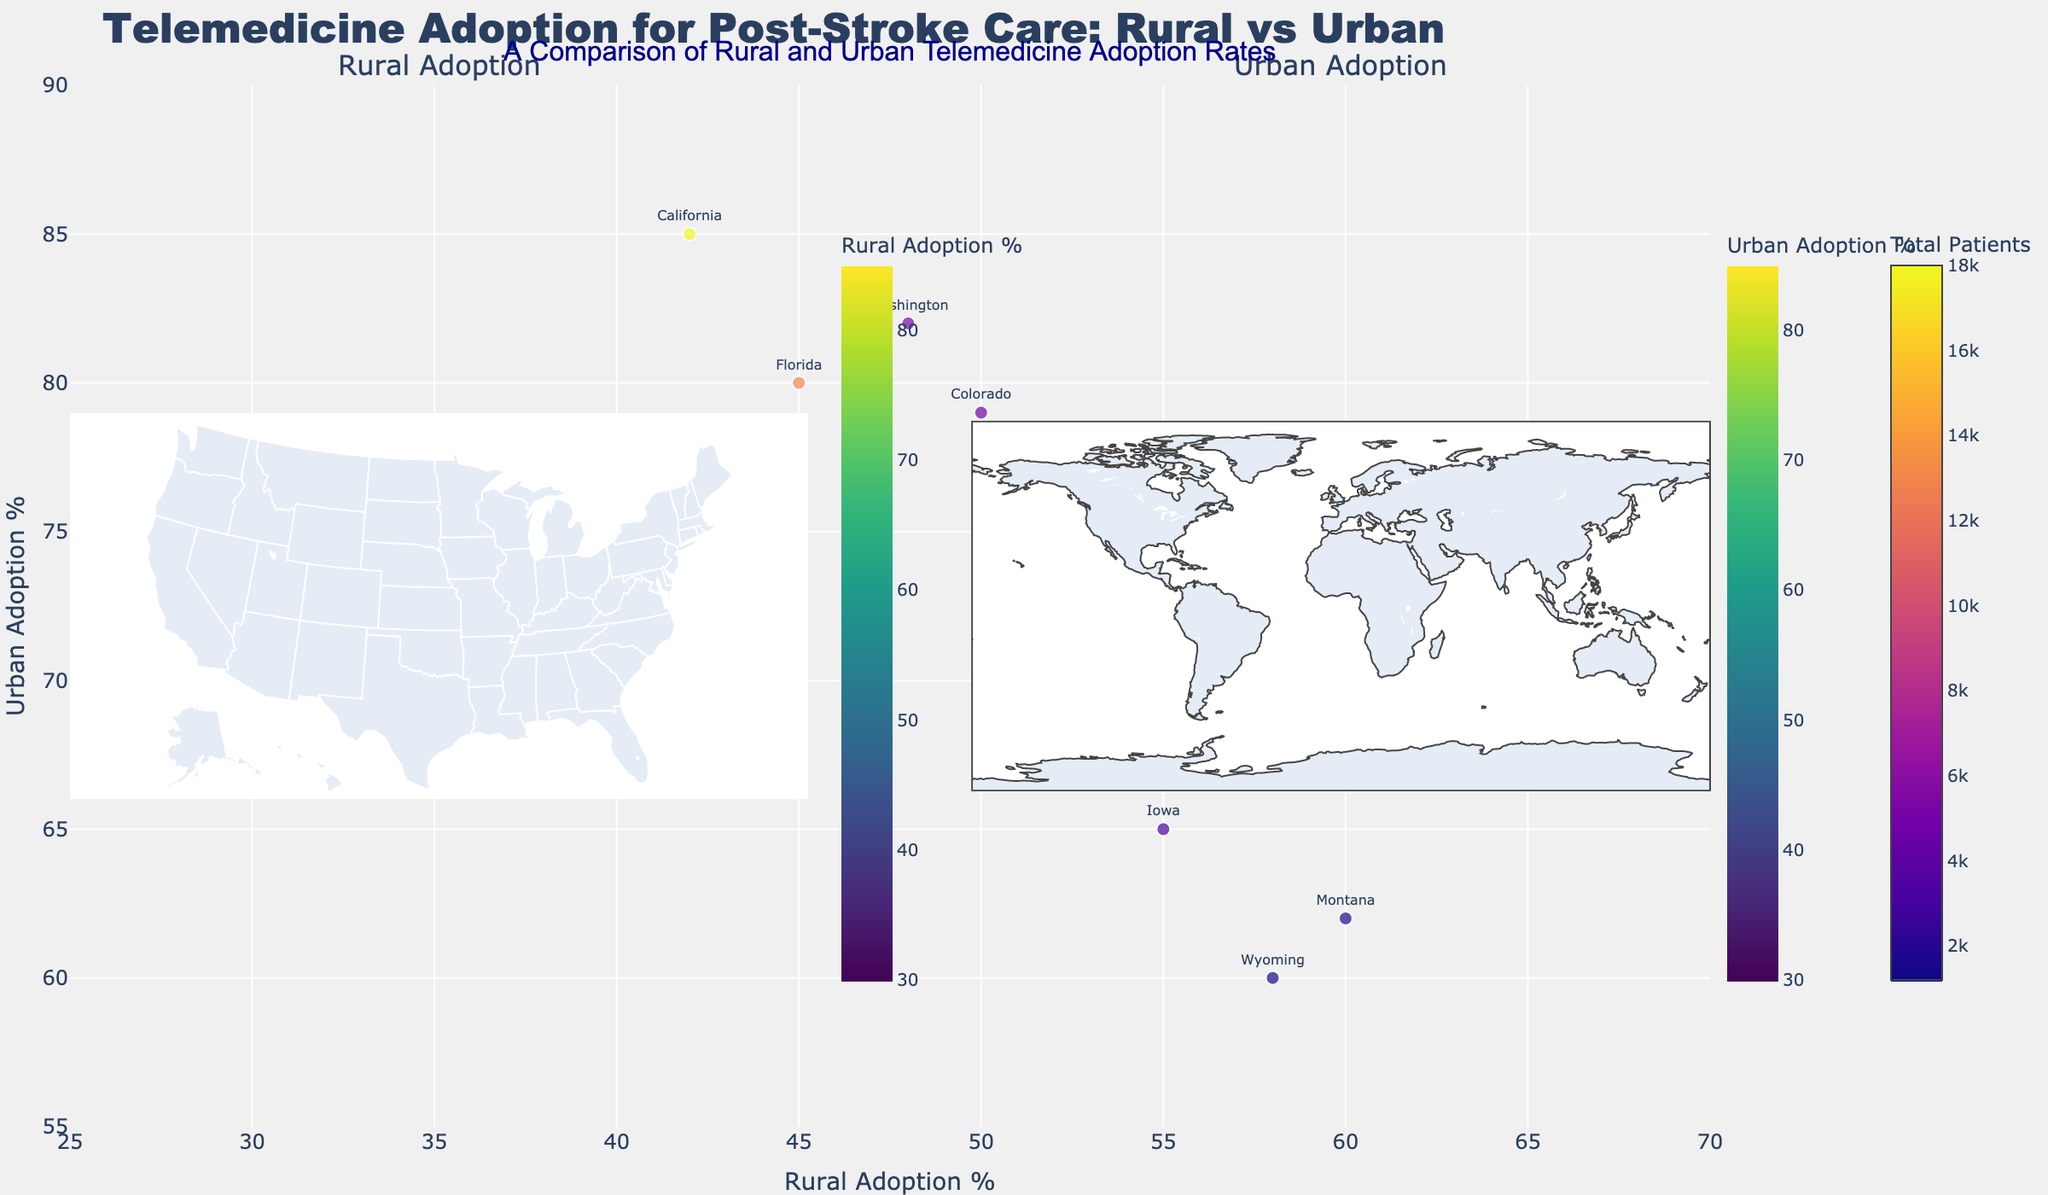What is the title of the figure? The title is generally located at the top of the figure. The title of this figure is "Telemedicine Adoption for Post-Stroke Care: Rural vs Urban."
Answer: Telemedicine Adoption for Post-Stroke Care: Rural vs Urban Which region has the highest rural adoption rate? Look at the rural adoption choropleth map and identify the region with the darkest color. According to the color scale, Alaska has the highest rural adoption rate.
Answer: Alaska How does the urban adoption rate in Texas compare to that in California? Compare the urban adoption values in Texas and California on the urban choropleth map or the bubble chart. Texas has an urban adoption rate of 72%, while California has 85%, indicating California’s rate is higher.
Answer: California's rate is higher What is the range of the urban adoption percentage shown on the figure? The color scale for urban adoption shows the range of values. The range is from the smallest urban adoption percentage (60% in Wyoming) to the highest percentage (85% in California).
Answer: 60% to 85% Which three regions have the smallest total number of patients? Look at the sizes of the bubbles on the bubble chart. The smallest bubbles represent Montana, Wyoming, and Alaska, which have the smallest total number of patients.
Answer: Montana, Wyoming, Alaska In which region is there a large gap between rural and urban telemedicine adoption rates? Identify regions with significant differences between rural and urban adoption by comparing the locations of bubbles horizontally and vertically. California, for instance, shows a large gap with rural adoption at 42% and urban adoption at 85%.
Answer: California What is the average rural adoption rate across all regions? Add up all the rural adoption percentages and divide by the number of regions. The sum of rural adoption rates is 730, and there are 15 regions, so the average is 730/15 = 48.67%.
Answer: 48.67% Which region exhibits a higher rural telemedicine adoption than urban, and what could be a possible explanation for this pattern? Identify regions where the rural adoption percentage exceeds urban adoption. Iowa, Montana, and Wyoming exhibit this pattern. These regions may have stronger rural healthcare initiatives or disparities in urban adoption for some reason.
Answer: Iowa, Montana, Wyoming 